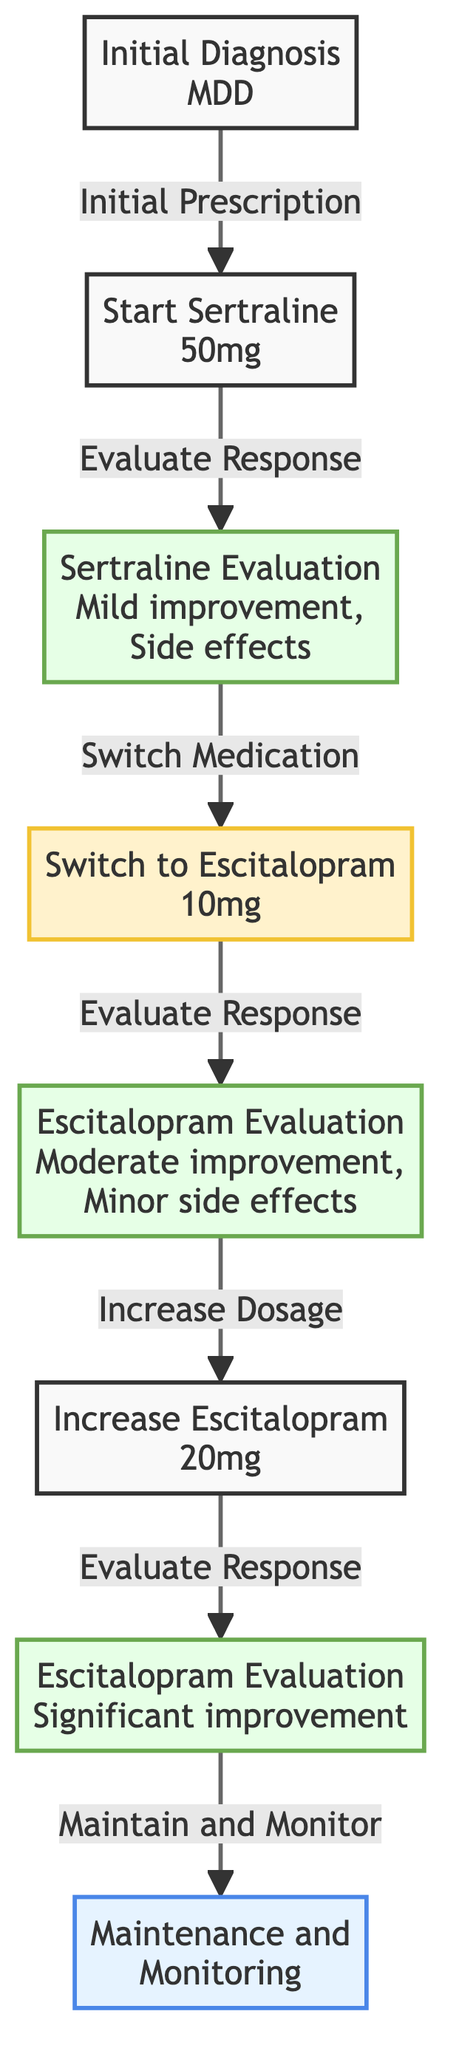What is the first node in the diagram? The first node is labeled "Initial Diagnosis" and describes the patient's diagnosis of Major Depressive Disorder (MDD).
Answer: Initial Diagnosis How many medications are prescribed in the journey? There are two medications prescribed during the patient response journey: Sertraline and Escitalopram.
Answer: Two What improvement occurs after increasing Escitalopram to 20mg? After increasing the dosage to 20mg, the evaluation shows significant improvement and the patient is stable.
Answer: Significant improvement What is the label for the edge from Sertraline Evaluation to Switch to Escitalopram? The label for that edge is "Switch Medication," indicating the decision to change medications due to side effects.
Answer: Switch Medication Which node represents the patient's evaluation after starting Escitalopram? The node representing the evaluation after starting Escitalopram is "Escitalopram Evaluation."
Answer: Escitalopram Evaluation What is the description of the last node in the diagram? The last node, "Maintenance and Monitoring," describes regular follow-ups to monitor ongoing response and side effects.
Answer: Maintenance and Monitoring Why was the decision made to switch from Sertraline? The decision was made to switch from Sertraline due to persistent side effects experienced by the patient, specifically nausea and insomnia.
Answer: Due to persistent side effects What is the relationship between "Increase Escitalopram" and "Escitalopram Evaluation"? The relationship is that after increasing the dosage to 20mg, the next step is to evaluate the patient's response to the higher dosage.
Answer: Evaluation after increase 